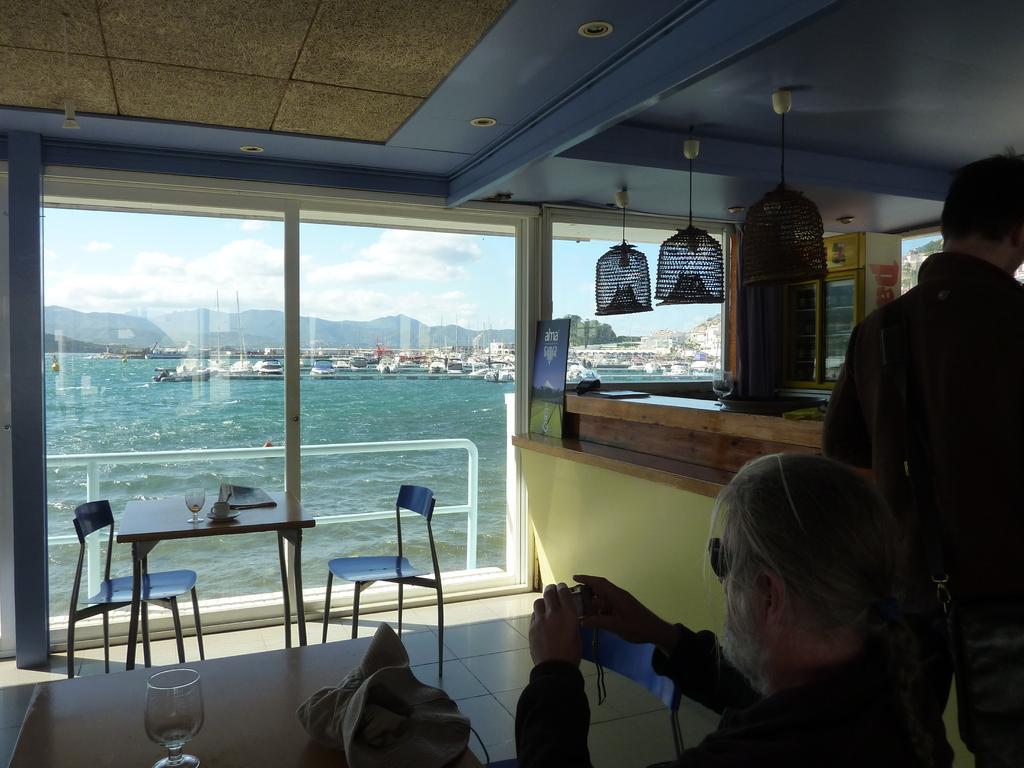Please provide a concise description of this image. In this picture we can see two people a person is seated on the chair, in front of the seated person we can see a bag and a glass on the table, and also we can see water and couple of buildings. 